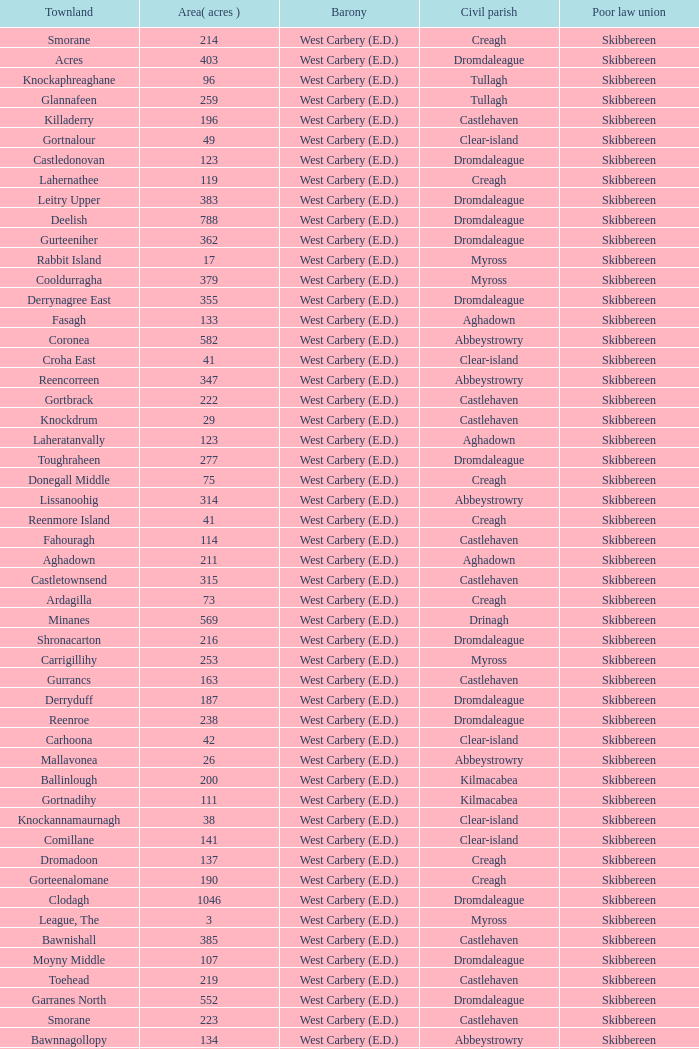What is the greatest area when the Poor Law Union is Skibbereen and the Civil Parish is Tullagh? 796.0. 